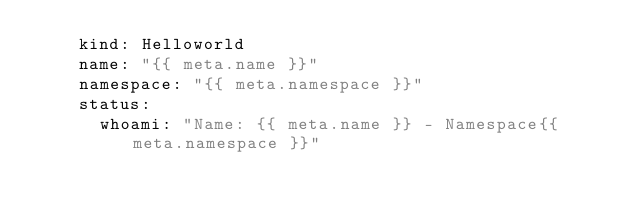<code> <loc_0><loc_0><loc_500><loc_500><_YAML_>    kind: Helloworld
    name: "{{ meta.name }}"
    namespace: "{{ meta.namespace }}"
    status:
      whoami: "Name: {{ meta.name }} - Namespace{{ meta.namespace }}"

</code> 